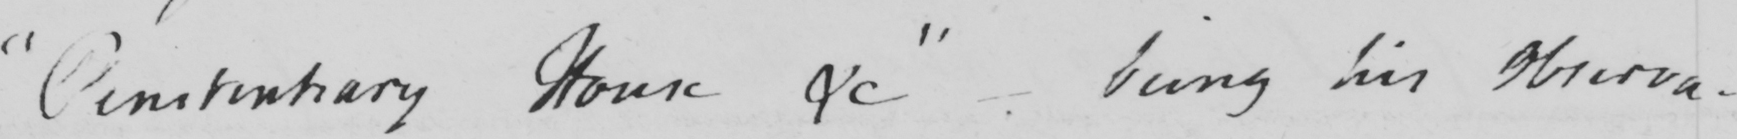Can you tell me what this handwritten text says? " Penitentiary House &c "   _  being his Observa- 